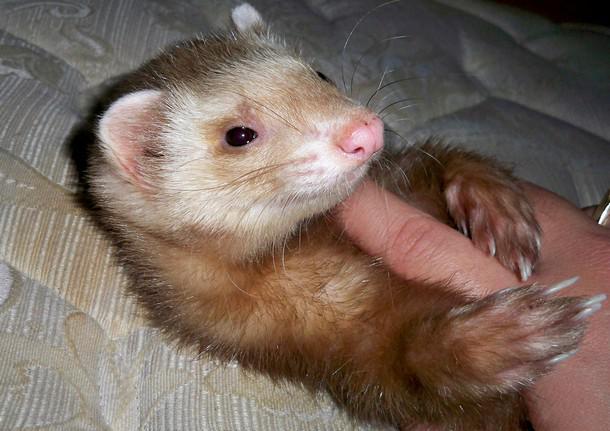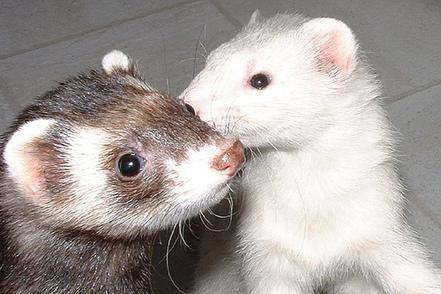The first image is the image on the left, the second image is the image on the right. Given the left and right images, does the statement "At least one ferret has an open mouth with tongue showing, and a total of three ferrets are shown." hold true? Answer yes or no. No. The first image is the image on the left, the second image is the image on the right. Assess this claim about the two images: "At least one of the ferrets has their tongue sticking out.". Correct or not? Answer yes or no. No. 